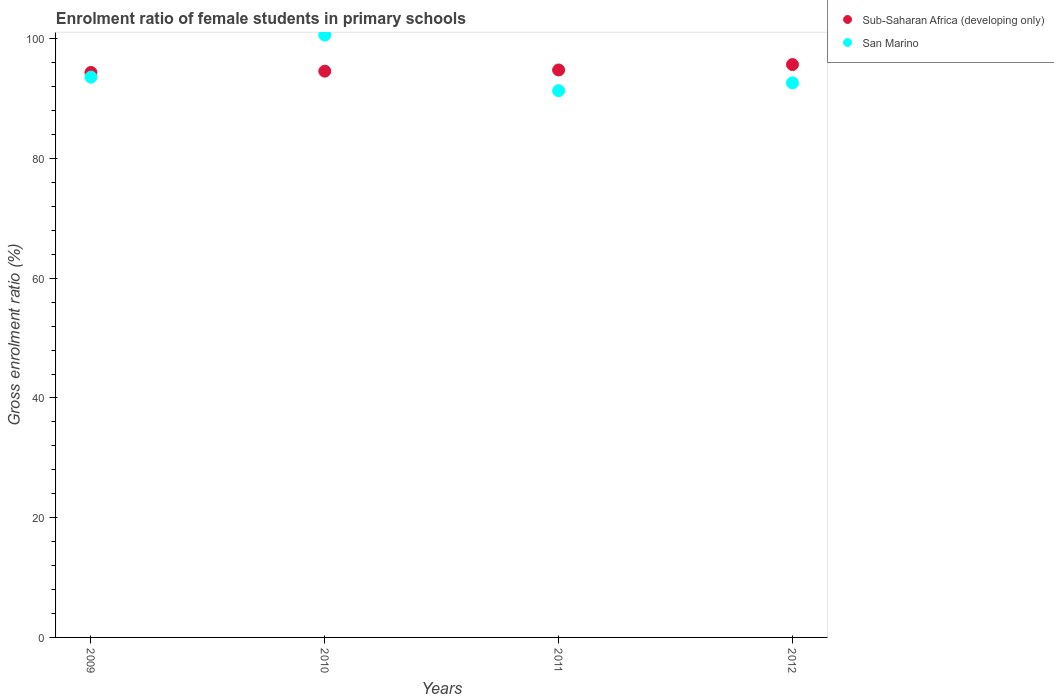How many different coloured dotlines are there?
Give a very brief answer. 2. Is the number of dotlines equal to the number of legend labels?
Keep it short and to the point. Yes. What is the enrolment ratio of female students in primary schools in Sub-Saharan Africa (developing only) in 2009?
Your answer should be very brief. 94.38. Across all years, what is the maximum enrolment ratio of female students in primary schools in San Marino?
Keep it short and to the point. 100.63. Across all years, what is the minimum enrolment ratio of female students in primary schools in San Marino?
Offer a very short reply. 91.34. In which year was the enrolment ratio of female students in primary schools in San Marino maximum?
Your answer should be compact. 2010. What is the total enrolment ratio of female students in primary schools in San Marino in the graph?
Offer a very short reply. 378.22. What is the difference between the enrolment ratio of female students in primary schools in San Marino in 2009 and that in 2011?
Your answer should be compact. 2.26. What is the difference between the enrolment ratio of female students in primary schools in Sub-Saharan Africa (developing only) in 2009 and the enrolment ratio of female students in primary schools in San Marino in 2012?
Make the answer very short. 1.74. What is the average enrolment ratio of female students in primary schools in Sub-Saharan Africa (developing only) per year?
Ensure brevity in your answer.  94.87. In the year 2012, what is the difference between the enrolment ratio of female students in primary schools in San Marino and enrolment ratio of female students in primary schools in Sub-Saharan Africa (developing only)?
Keep it short and to the point. -3.06. What is the ratio of the enrolment ratio of female students in primary schools in Sub-Saharan Africa (developing only) in 2011 to that in 2012?
Keep it short and to the point. 0.99. Is the enrolment ratio of female students in primary schools in San Marino in 2009 less than that in 2012?
Your response must be concise. No. What is the difference between the highest and the second highest enrolment ratio of female students in primary schools in San Marino?
Make the answer very short. 7.03. What is the difference between the highest and the lowest enrolment ratio of female students in primary schools in Sub-Saharan Africa (developing only)?
Give a very brief answer. 1.32. In how many years, is the enrolment ratio of female students in primary schools in San Marino greater than the average enrolment ratio of female students in primary schools in San Marino taken over all years?
Your answer should be very brief. 1. Does the enrolment ratio of female students in primary schools in Sub-Saharan Africa (developing only) monotonically increase over the years?
Provide a short and direct response. Yes. Is the enrolment ratio of female students in primary schools in San Marino strictly greater than the enrolment ratio of female students in primary schools in Sub-Saharan Africa (developing only) over the years?
Provide a succinct answer. No. Is the enrolment ratio of female students in primary schools in Sub-Saharan Africa (developing only) strictly less than the enrolment ratio of female students in primary schools in San Marino over the years?
Your answer should be compact. No. How many dotlines are there?
Make the answer very short. 2. What is the difference between two consecutive major ticks on the Y-axis?
Your answer should be compact. 20. Are the values on the major ticks of Y-axis written in scientific E-notation?
Give a very brief answer. No. Does the graph contain any zero values?
Your response must be concise. No. Does the graph contain grids?
Your answer should be very brief. No. What is the title of the graph?
Give a very brief answer. Enrolment ratio of female students in primary schools. What is the Gross enrolment ratio (%) in Sub-Saharan Africa (developing only) in 2009?
Offer a terse response. 94.38. What is the Gross enrolment ratio (%) of San Marino in 2009?
Provide a succinct answer. 93.6. What is the Gross enrolment ratio (%) in Sub-Saharan Africa (developing only) in 2010?
Keep it short and to the point. 94.59. What is the Gross enrolment ratio (%) in San Marino in 2010?
Offer a terse response. 100.63. What is the Gross enrolment ratio (%) in Sub-Saharan Africa (developing only) in 2011?
Give a very brief answer. 94.8. What is the Gross enrolment ratio (%) in San Marino in 2011?
Offer a terse response. 91.34. What is the Gross enrolment ratio (%) of Sub-Saharan Africa (developing only) in 2012?
Your response must be concise. 95.7. What is the Gross enrolment ratio (%) in San Marino in 2012?
Your answer should be compact. 92.65. Across all years, what is the maximum Gross enrolment ratio (%) of Sub-Saharan Africa (developing only)?
Provide a short and direct response. 95.7. Across all years, what is the maximum Gross enrolment ratio (%) of San Marino?
Your answer should be compact. 100.63. Across all years, what is the minimum Gross enrolment ratio (%) of Sub-Saharan Africa (developing only)?
Keep it short and to the point. 94.38. Across all years, what is the minimum Gross enrolment ratio (%) in San Marino?
Offer a very short reply. 91.34. What is the total Gross enrolment ratio (%) of Sub-Saharan Africa (developing only) in the graph?
Ensure brevity in your answer.  379.47. What is the total Gross enrolment ratio (%) of San Marino in the graph?
Your answer should be compact. 378.22. What is the difference between the Gross enrolment ratio (%) of Sub-Saharan Africa (developing only) in 2009 and that in 2010?
Provide a short and direct response. -0.21. What is the difference between the Gross enrolment ratio (%) in San Marino in 2009 and that in 2010?
Make the answer very short. -7.03. What is the difference between the Gross enrolment ratio (%) in Sub-Saharan Africa (developing only) in 2009 and that in 2011?
Ensure brevity in your answer.  -0.42. What is the difference between the Gross enrolment ratio (%) of San Marino in 2009 and that in 2011?
Provide a succinct answer. 2.26. What is the difference between the Gross enrolment ratio (%) of Sub-Saharan Africa (developing only) in 2009 and that in 2012?
Keep it short and to the point. -1.32. What is the difference between the Gross enrolment ratio (%) in San Marino in 2009 and that in 2012?
Your answer should be very brief. 0.96. What is the difference between the Gross enrolment ratio (%) in Sub-Saharan Africa (developing only) in 2010 and that in 2011?
Give a very brief answer. -0.2. What is the difference between the Gross enrolment ratio (%) of San Marino in 2010 and that in 2011?
Offer a terse response. 9.3. What is the difference between the Gross enrolment ratio (%) in Sub-Saharan Africa (developing only) in 2010 and that in 2012?
Provide a succinct answer. -1.11. What is the difference between the Gross enrolment ratio (%) in San Marino in 2010 and that in 2012?
Offer a terse response. 7.99. What is the difference between the Gross enrolment ratio (%) in Sub-Saharan Africa (developing only) in 2011 and that in 2012?
Give a very brief answer. -0.91. What is the difference between the Gross enrolment ratio (%) in San Marino in 2011 and that in 2012?
Keep it short and to the point. -1.31. What is the difference between the Gross enrolment ratio (%) of Sub-Saharan Africa (developing only) in 2009 and the Gross enrolment ratio (%) of San Marino in 2010?
Offer a very short reply. -6.25. What is the difference between the Gross enrolment ratio (%) of Sub-Saharan Africa (developing only) in 2009 and the Gross enrolment ratio (%) of San Marino in 2011?
Your answer should be very brief. 3.04. What is the difference between the Gross enrolment ratio (%) of Sub-Saharan Africa (developing only) in 2009 and the Gross enrolment ratio (%) of San Marino in 2012?
Offer a very short reply. 1.74. What is the difference between the Gross enrolment ratio (%) in Sub-Saharan Africa (developing only) in 2010 and the Gross enrolment ratio (%) in San Marino in 2011?
Offer a terse response. 3.26. What is the difference between the Gross enrolment ratio (%) of Sub-Saharan Africa (developing only) in 2010 and the Gross enrolment ratio (%) of San Marino in 2012?
Keep it short and to the point. 1.95. What is the difference between the Gross enrolment ratio (%) in Sub-Saharan Africa (developing only) in 2011 and the Gross enrolment ratio (%) in San Marino in 2012?
Your answer should be very brief. 2.15. What is the average Gross enrolment ratio (%) of Sub-Saharan Africa (developing only) per year?
Your answer should be compact. 94.87. What is the average Gross enrolment ratio (%) of San Marino per year?
Ensure brevity in your answer.  94.55. In the year 2009, what is the difference between the Gross enrolment ratio (%) of Sub-Saharan Africa (developing only) and Gross enrolment ratio (%) of San Marino?
Ensure brevity in your answer.  0.78. In the year 2010, what is the difference between the Gross enrolment ratio (%) in Sub-Saharan Africa (developing only) and Gross enrolment ratio (%) in San Marino?
Your response must be concise. -6.04. In the year 2011, what is the difference between the Gross enrolment ratio (%) of Sub-Saharan Africa (developing only) and Gross enrolment ratio (%) of San Marino?
Make the answer very short. 3.46. In the year 2012, what is the difference between the Gross enrolment ratio (%) of Sub-Saharan Africa (developing only) and Gross enrolment ratio (%) of San Marino?
Ensure brevity in your answer.  3.06. What is the ratio of the Gross enrolment ratio (%) of San Marino in 2009 to that in 2010?
Provide a succinct answer. 0.93. What is the ratio of the Gross enrolment ratio (%) in San Marino in 2009 to that in 2011?
Ensure brevity in your answer.  1.02. What is the ratio of the Gross enrolment ratio (%) in Sub-Saharan Africa (developing only) in 2009 to that in 2012?
Give a very brief answer. 0.99. What is the ratio of the Gross enrolment ratio (%) of San Marino in 2009 to that in 2012?
Give a very brief answer. 1.01. What is the ratio of the Gross enrolment ratio (%) in Sub-Saharan Africa (developing only) in 2010 to that in 2011?
Make the answer very short. 1. What is the ratio of the Gross enrolment ratio (%) in San Marino in 2010 to that in 2011?
Offer a terse response. 1.1. What is the ratio of the Gross enrolment ratio (%) of Sub-Saharan Africa (developing only) in 2010 to that in 2012?
Your response must be concise. 0.99. What is the ratio of the Gross enrolment ratio (%) in San Marino in 2010 to that in 2012?
Keep it short and to the point. 1.09. What is the ratio of the Gross enrolment ratio (%) of Sub-Saharan Africa (developing only) in 2011 to that in 2012?
Provide a succinct answer. 0.99. What is the ratio of the Gross enrolment ratio (%) in San Marino in 2011 to that in 2012?
Provide a succinct answer. 0.99. What is the difference between the highest and the second highest Gross enrolment ratio (%) in Sub-Saharan Africa (developing only)?
Your answer should be compact. 0.91. What is the difference between the highest and the second highest Gross enrolment ratio (%) in San Marino?
Ensure brevity in your answer.  7.03. What is the difference between the highest and the lowest Gross enrolment ratio (%) in Sub-Saharan Africa (developing only)?
Provide a short and direct response. 1.32. What is the difference between the highest and the lowest Gross enrolment ratio (%) in San Marino?
Provide a short and direct response. 9.3. 